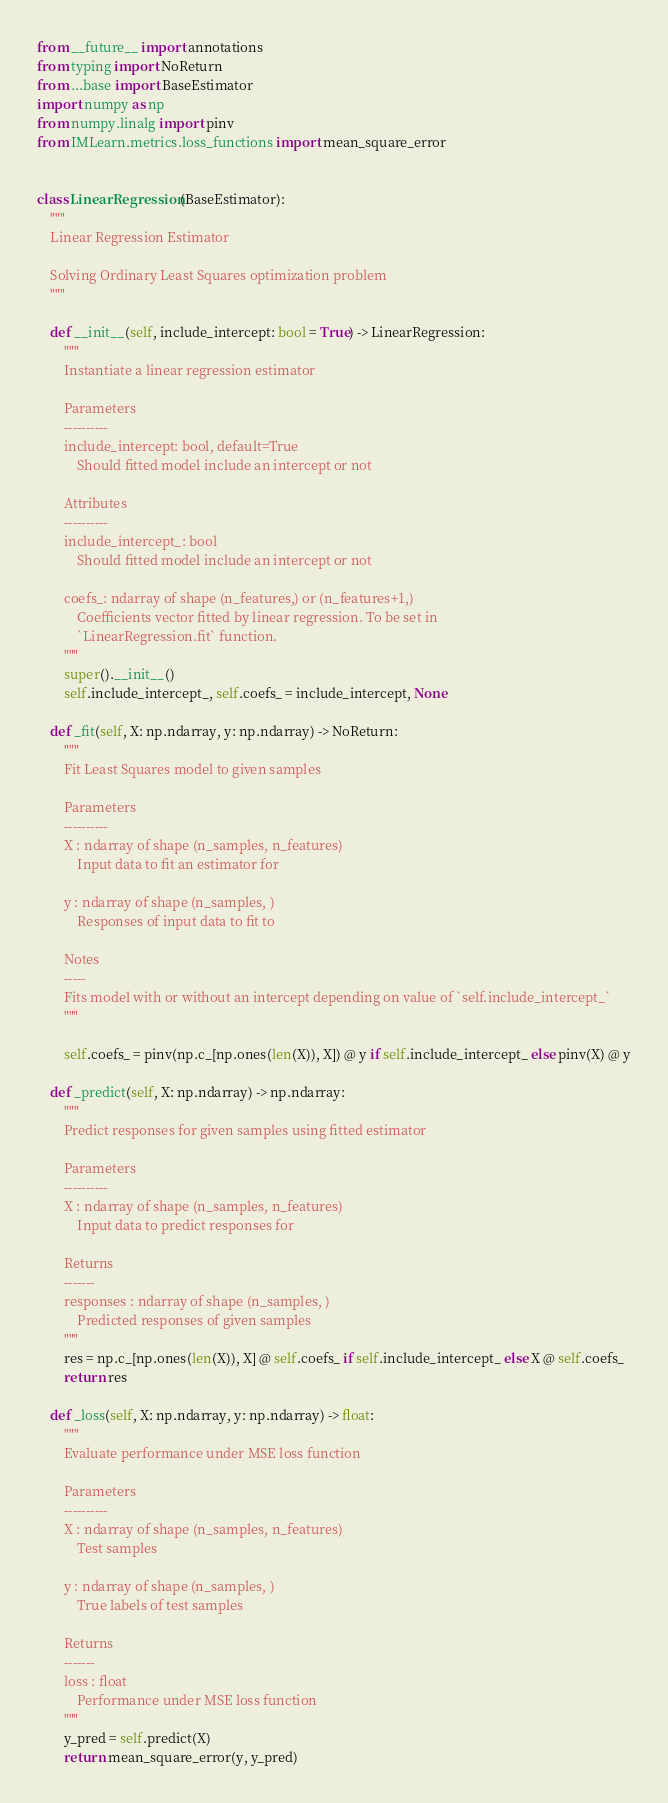<code> <loc_0><loc_0><loc_500><loc_500><_Python_>from __future__ import annotations
from typing import NoReturn
from ...base import BaseEstimator
import numpy as np
from numpy.linalg import pinv
from IMLearn.metrics.loss_functions import mean_square_error


class LinearRegression(BaseEstimator):
    """
    Linear Regression Estimator

    Solving Ordinary Least Squares optimization problem
    """

    def __init__(self, include_intercept: bool = True) -> LinearRegression:
        """
        Instantiate a linear regression estimator

        Parameters
        ----------
        include_intercept: bool, default=True
            Should fitted model include an intercept or not

        Attributes
        ----------
        include_intercept_: bool
            Should fitted model include an intercept or not

        coefs_: ndarray of shape (n_features,) or (n_features+1,)
            Coefficients vector fitted by linear regression. To be set in
            `LinearRegression.fit` function.
        """
        super().__init__()
        self.include_intercept_, self.coefs_ = include_intercept, None

    def _fit(self, X: np.ndarray, y: np.ndarray) -> NoReturn:
        """
        Fit Least Squares model to given samples

        Parameters
        ----------
        X : ndarray of shape (n_samples, n_features)
            Input data to fit an estimator for

        y : ndarray of shape (n_samples, )
            Responses of input data to fit to

        Notes
        -----
        Fits model with or without an intercept depending on value of `self.include_intercept_`
        """

        self.coefs_ = pinv(np.c_[np.ones(len(X)), X]) @ y if self.include_intercept_ else pinv(X) @ y

    def _predict(self, X: np.ndarray) -> np.ndarray:
        """
        Predict responses for given samples using fitted estimator

        Parameters
        ----------
        X : ndarray of shape (n_samples, n_features)
            Input data to predict responses for

        Returns
        -------
        responses : ndarray of shape (n_samples, )
            Predicted responses of given samples
        """
        res = np.c_[np.ones(len(X)), X] @ self.coefs_ if self.include_intercept_ else X @ self.coefs_
        return res

    def _loss(self, X: np.ndarray, y: np.ndarray) -> float:
        """
        Evaluate performance under MSE loss function

        Parameters
        ----------
        X : ndarray of shape (n_samples, n_features)
            Test samples

        y : ndarray of shape (n_samples, )
            True labels of test samples

        Returns
        -------
        loss : float
            Performance under MSE loss function
        """
        y_pred = self.predict(X)
        return mean_square_error(y, y_pred)
</code> 